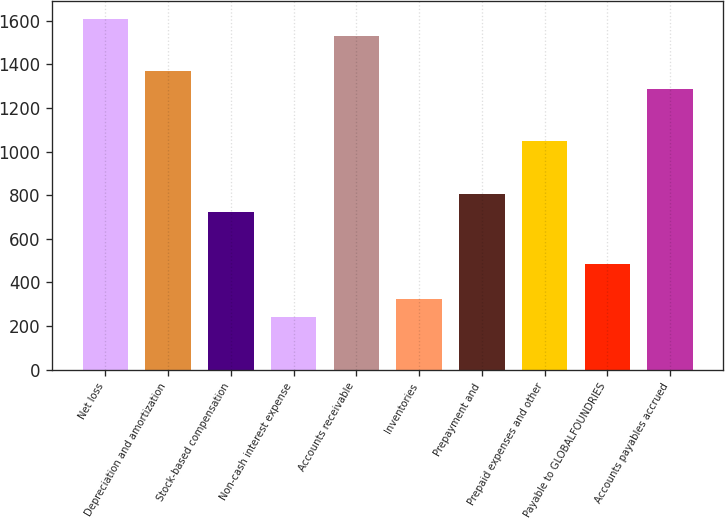Convert chart. <chart><loc_0><loc_0><loc_500><loc_500><bar_chart><fcel>Net loss<fcel>Depreciation and amortization<fcel>Stock-based compensation<fcel>Non-cash interest expense<fcel>Accounts receivable<fcel>Inventories<fcel>Prepayment and<fcel>Prepaid expenses and other<fcel>Payable to GLOBALFOUNDRIES<fcel>Accounts payables accrued<nl><fcel>1608<fcel>1367.1<fcel>724.7<fcel>242.9<fcel>1527.7<fcel>323.2<fcel>805<fcel>1045.9<fcel>483.8<fcel>1286.8<nl></chart> 